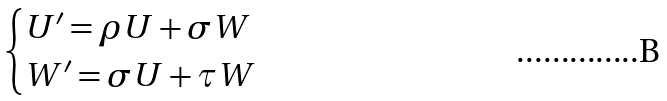Convert formula to latex. <formula><loc_0><loc_0><loc_500><loc_500>\begin{cases} U ^ { \prime } = \rho U + \sigma W \\ W ^ { \prime } = \sigma U + \tau W \\ \end{cases}</formula> 